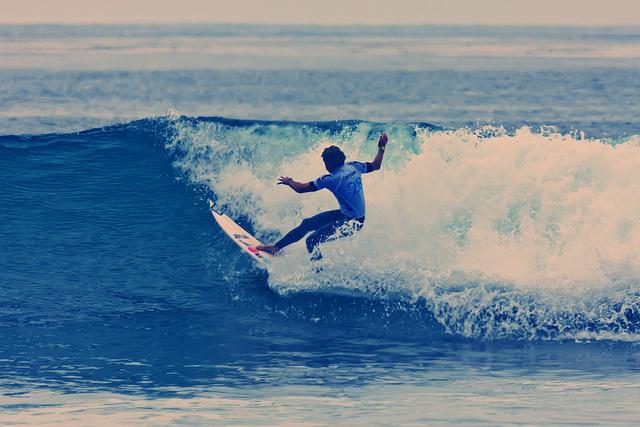What is the name of the outfit the person is wearing?
Keep it brief. Wetsuit. What color is the man's shirt?
Answer briefly. Blue. Does it take balance to enjoy this sport?
Short answer required. Yes. Is the sea water brown color?
Write a very short answer. No. What color is the ground?
Short answer required. Blue. Is the man riding a large wave?
Be succinct. Yes. Is the surfer in a wetsuit?
Answer briefly. Yes. 